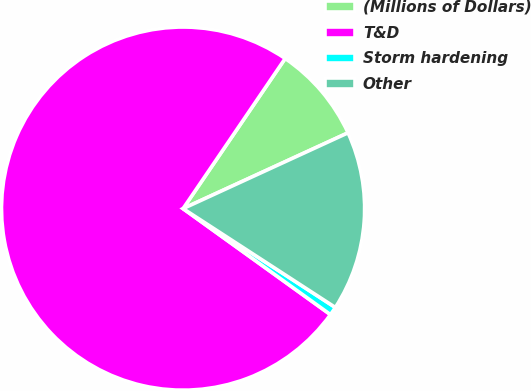<chart> <loc_0><loc_0><loc_500><loc_500><pie_chart><fcel>(Millions of Dollars)<fcel>T&D<fcel>Storm hardening<fcel>Other<nl><fcel>8.64%<fcel>74.59%<fcel>0.76%<fcel>16.02%<nl></chart> 